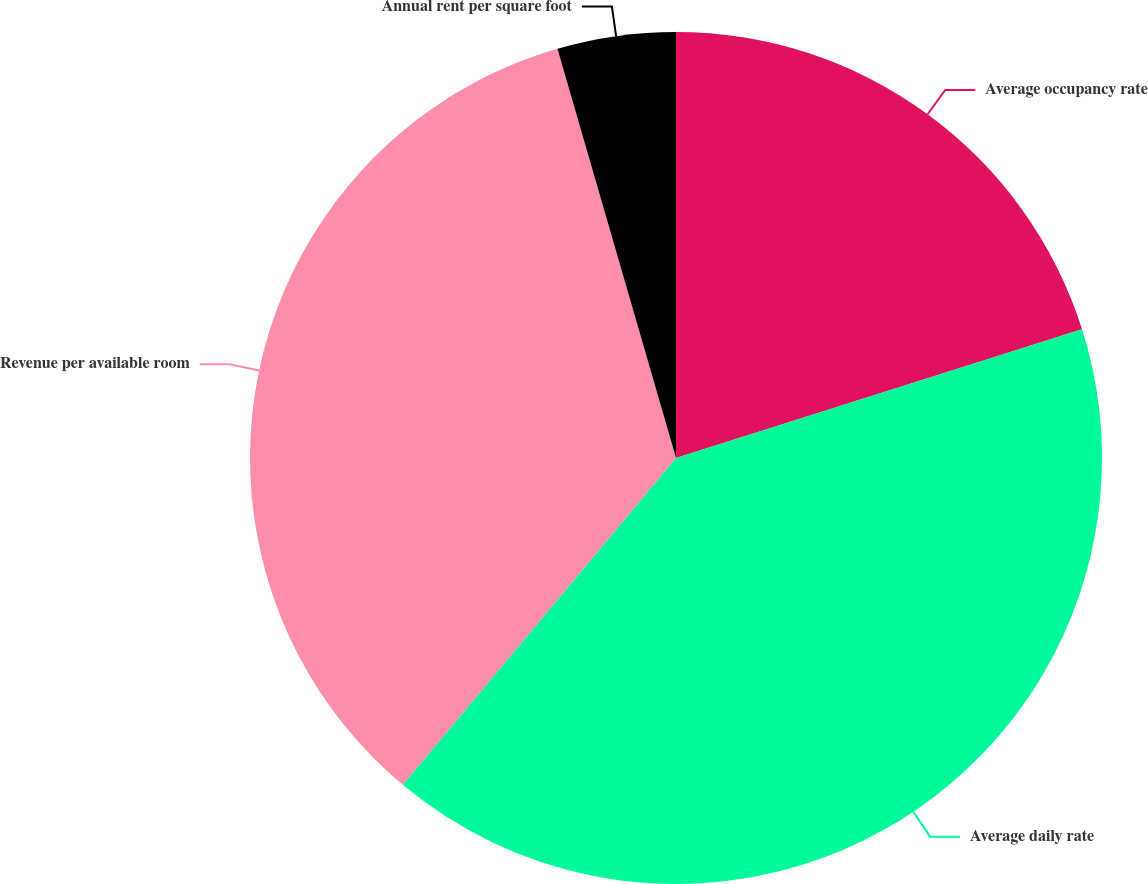<chart> <loc_0><loc_0><loc_500><loc_500><pie_chart><fcel>Average occupancy rate<fcel>Average daily rate<fcel>Revenue per available room<fcel>Annual rent per square foot<nl><fcel>20.11%<fcel>40.97%<fcel>34.43%<fcel>4.49%<nl></chart> 